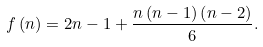<formula> <loc_0><loc_0><loc_500><loc_500>f \left ( n \right ) = 2 n - 1 + \frac { n \left ( n - 1 \right ) \left ( n - 2 \right ) } { 6 } .</formula> 